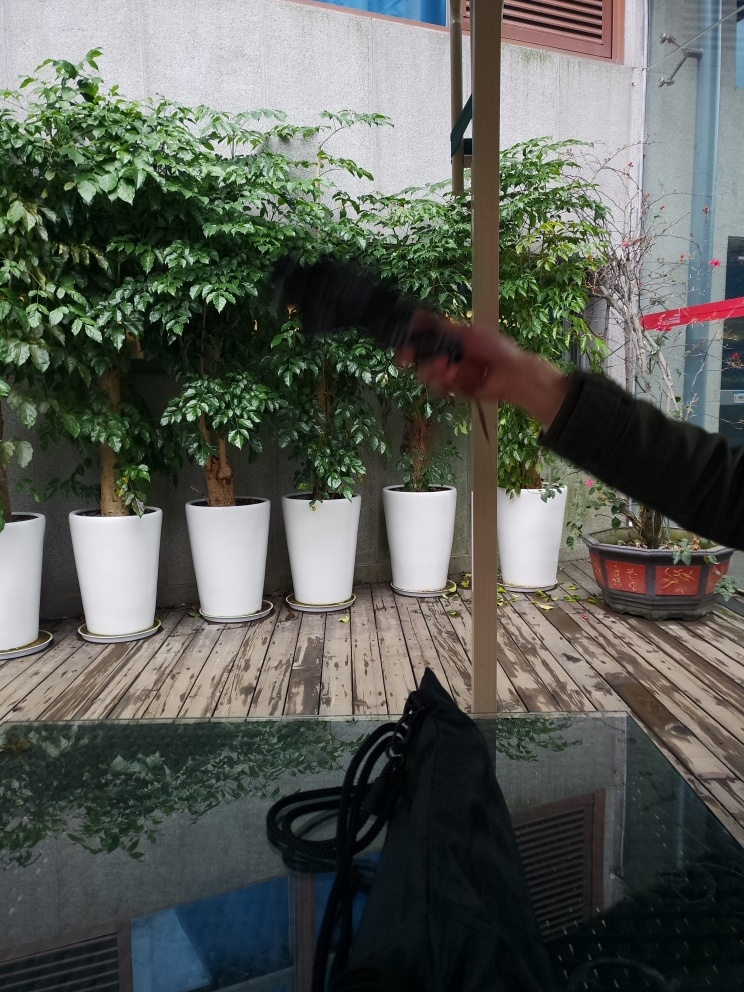Is there rich texture detail in the background vegetation? Upon closer examination, the background vegetation exhibits a variety of shades and leaf patterns, adding a subtle richness to the texture. Although not overly intricate, the foliage does provide a pleasing level of detail that complements the scene. 